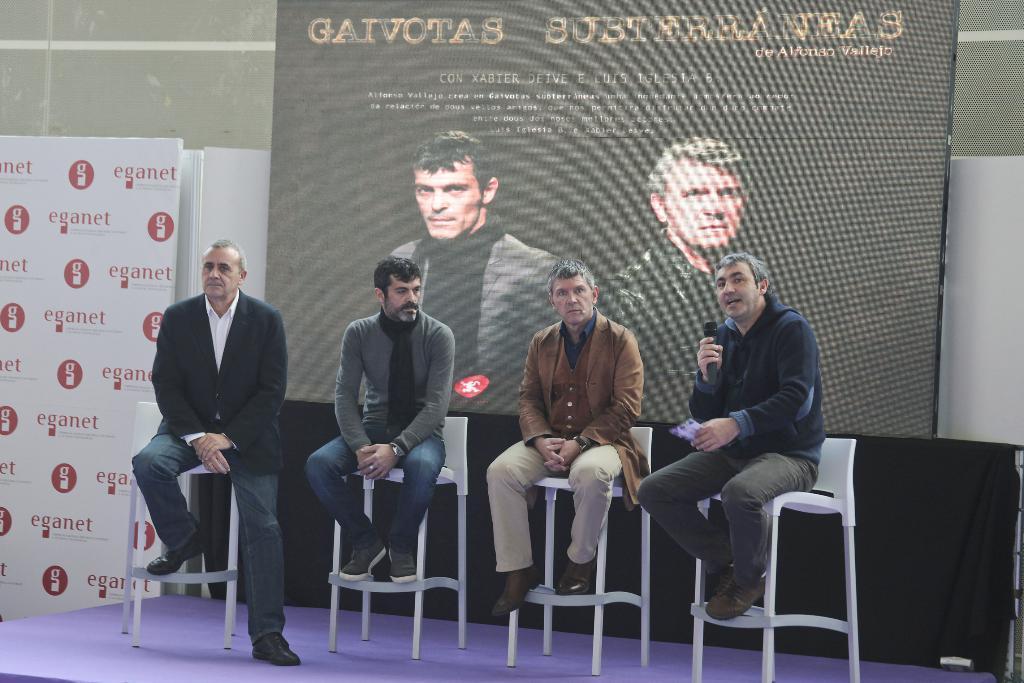Please provide a concise description of this image. These four persons are sitting on a chair. This man is holding a mic. On this banner there are pictures of persons. 